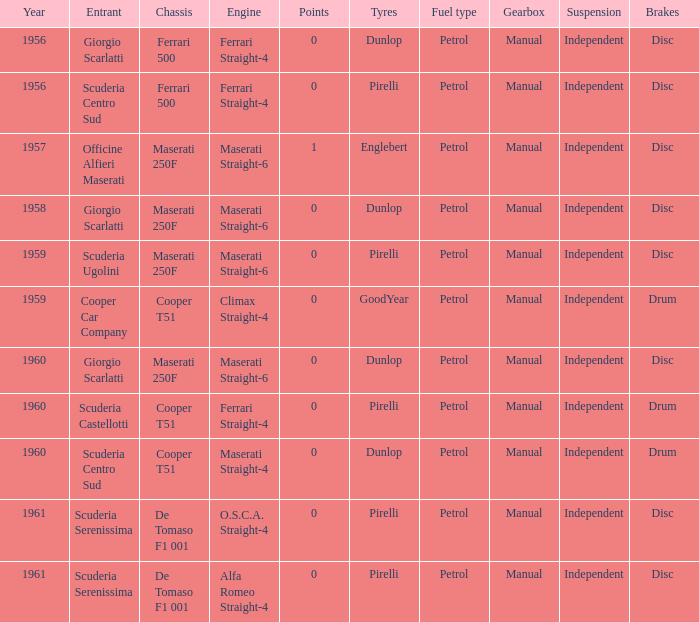How many points for the cooper car company after 1959? None. 